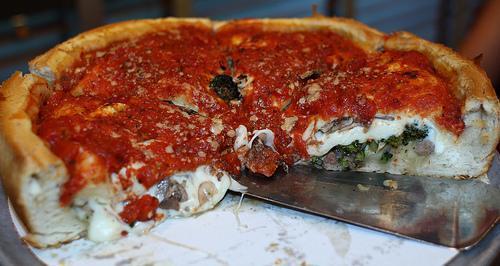How many pizzas are there?
Give a very brief answer. 1. 